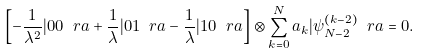Convert formula to latex. <formula><loc_0><loc_0><loc_500><loc_500>\left [ - \frac { 1 } { \lambda ^ { 2 } } | 0 0 \ r a + \frac { 1 } { \lambda } | 0 1 \ r a - \frac { 1 } { \lambda } | 1 0 \ r a \right ] \otimes \sum _ { k = 0 } ^ { N } a _ { k } | \psi _ { N - 2 } ^ { ( k - 2 ) } \ r a = 0 .</formula> 